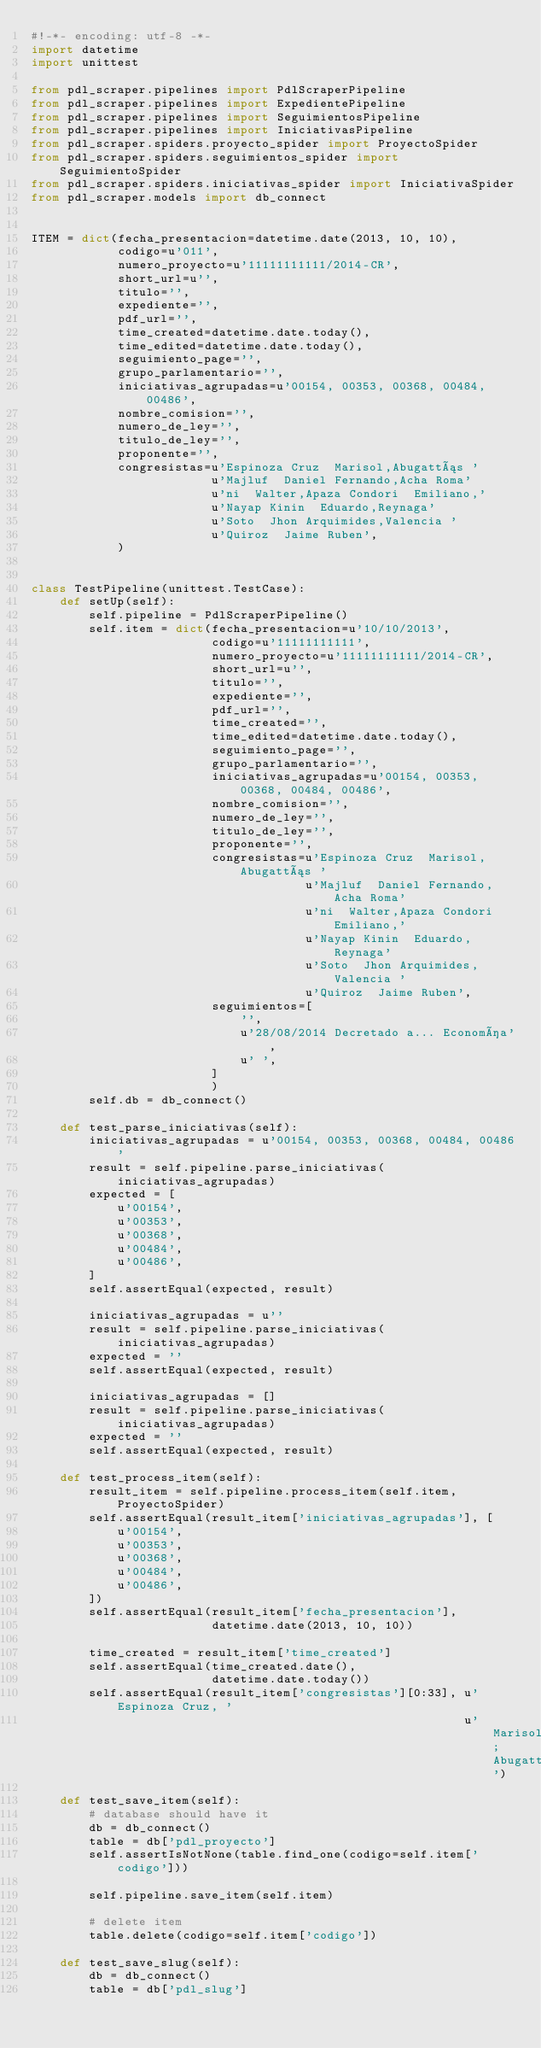<code> <loc_0><loc_0><loc_500><loc_500><_Python_>#!-*- encoding: utf-8 -*-
import datetime
import unittest

from pdl_scraper.pipelines import PdlScraperPipeline
from pdl_scraper.pipelines import ExpedientePipeline
from pdl_scraper.pipelines import SeguimientosPipeline
from pdl_scraper.pipelines import IniciativasPipeline
from pdl_scraper.spiders.proyecto_spider import ProyectoSpider
from pdl_scraper.spiders.seguimientos_spider import SeguimientoSpider
from pdl_scraper.spiders.iniciativas_spider import IniciativaSpider
from pdl_scraper.models import db_connect


ITEM = dict(fecha_presentacion=datetime.date(2013, 10, 10),
            codigo=u'011',
            numero_proyecto=u'11111111111/2014-CR',
            short_url=u'',
            titulo='',
            expediente='',
            pdf_url='',
            time_created=datetime.date.today(),
            time_edited=datetime.date.today(),
            seguimiento_page='',
            grupo_parlamentario='',
            iniciativas_agrupadas=u'00154, 00353, 00368, 00484, 00486',
            nombre_comision='',
            numero_de_ley='',
            titulo_de_ley='',
            proponente='',
            congresistas=u'Espinoza Cruz  Marisol,Abugattás '
                         u'Majluf  Daniel Fernando,Acha Roma'
                         u'ni  Walter,Apaza Condori  Emiliano,'
                         u'Nayap Kinin  Eduardo,Reynaga'
                         u'Soto  Jhon Arquimides,Valencia '
                         u'Quiroz  Jaime Ruben',
            )


class TestPipeline(unittest.TestCase):
    def setUp(self):
        self.pipeline = PdlScraperPipeline()
        self.item = dict(fecha_presentacion=u'10/10/2013',
                         codigo=u'11111111111',
                         numero_proyecto=u'11111111111/2014-CR',
                         short_url=u'',
                         titulo='',
                         expediente='',
                         pdf_url='',
                         time_created='',
                         time_edited=datetime.date.today(),
                         seguimiento_page='',
                         grupo_parlamentario='',
                         iniciativas_agrupadas=u'00154, 00353, 00368, 00484, 00486',
                         nombre_comision='',
                         numero_de_ley='',
                         titulo_de_ley='',
                         proponente='',
                         congresistas=u'Espinoza Cruz  Marisol,Abugattás '
                                      u'Majluf  Daniel Fernando,Acha Roma'
                                      u'ni  Walter,Apaza Condori  Emiliano,'
                                      u'Nayap Kinin  Eduardo,Reynaga'
                                      u'Soto  Jhon Arquimides,Valencia '
                                      u'Quiroz  Jaime Ruben',
                         seguimientos=[
                             '',
                             u'28/08/2014 Decretado a... Economía',
                             u' ',
                         ]
                         )
        self.db = db_connect()

    def test_parse_iniciativas(self):
        iniciativas_agrupadas = u'00154, 00353, 00368, 00484, 00486'
        result = self.pipeline.parse_iniciativas(iniciativas_agrupadas)
        expected = [
            u'00154',
            u'00353',
            u'00368',
            u'00484',
            u'00486',
        ]
        self.assertEqual(expected, result)

        iniciativas_agrupadas = u''
        result = self.pipeline.parse_iniciativas(iniciativas_agrupadas)
        expected = ''
        self.assertEqual(expected, result)

        iniciativas_agrupadas = []
        result = self.pipeline.parse_iniciativas(iniciativas_agrupadas)
        expected = ''
        self.assertEqual(expected, result)

    def test_process_item(self):
        result_item = self.pipeline.process_item(self.item, ProyectoSpider)
        self.assertEqual(result_item['iniciativas_agrupadas'], [
            u'00154',
            u'00353',
            u'00368',
            u'00484',
            u'00486',
        ])
        self.assertEqual(result_item['fecha_presentacion'],
                         datetime.date(2013, 10, 10))

        time_created = result_item['time_created']
        self.assertEqual(time_created.date(),
                         datetime.date.today())
        self.assertEqual(result_item['congresistas'][0:33], u'Espinoza Cruz, '
                                                            u'Marisol; Abugattás')

    def test_save_item(self):
        # database should have it
        db = db_connect()
        table = db['pdl_proyecto']
        self.assertIsNotNone(table.find_one(codigo=self.item['codigo']))

        self.pipeline.save_item(self.item)

        # delete item
        table.delete(codigo=self.item['codigo'])

    def test_save_slug(self):
        db = db_connect()
        table = db['pdl_slug']</code> 